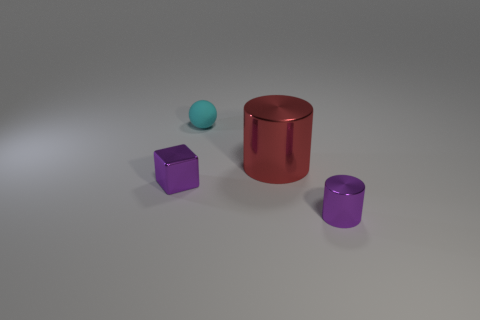Are there any other things that have the same size as the red metallic cylinder?
Offer a very short reply. No. What number of other big shiny things are the same shape as the red object?
Your answer should be compact. 0. What is the color of the matte thing that is the same size as the purple cylinder?
Offer a terse response. Cyan. Are there the same number of purple objects behind the purple shiny cylinder and small matte balls that are left of the tiny purple shiny block?
Provide a succinct answer. No. Is there a metal thing of the same size as the purple cylinder?
Your response must be concise. Yes. The cyan matte object has what size?
Offer a very short reply. Small. Are there the same number of big red things in front of the big red object and objects?
Your response must be concise. No. What number of other objects are the same color as the cube?
Ensure brevity in your answer.  1. The tiny thing that is both on the right side of the block and in front of the sphere is what color?
Provide a succinct answer. Purple. There is a shiny object behind the purple object to the left of the small thing to the right of the big thing; how big is it?
Ensure brevity in your answer.  Large. 